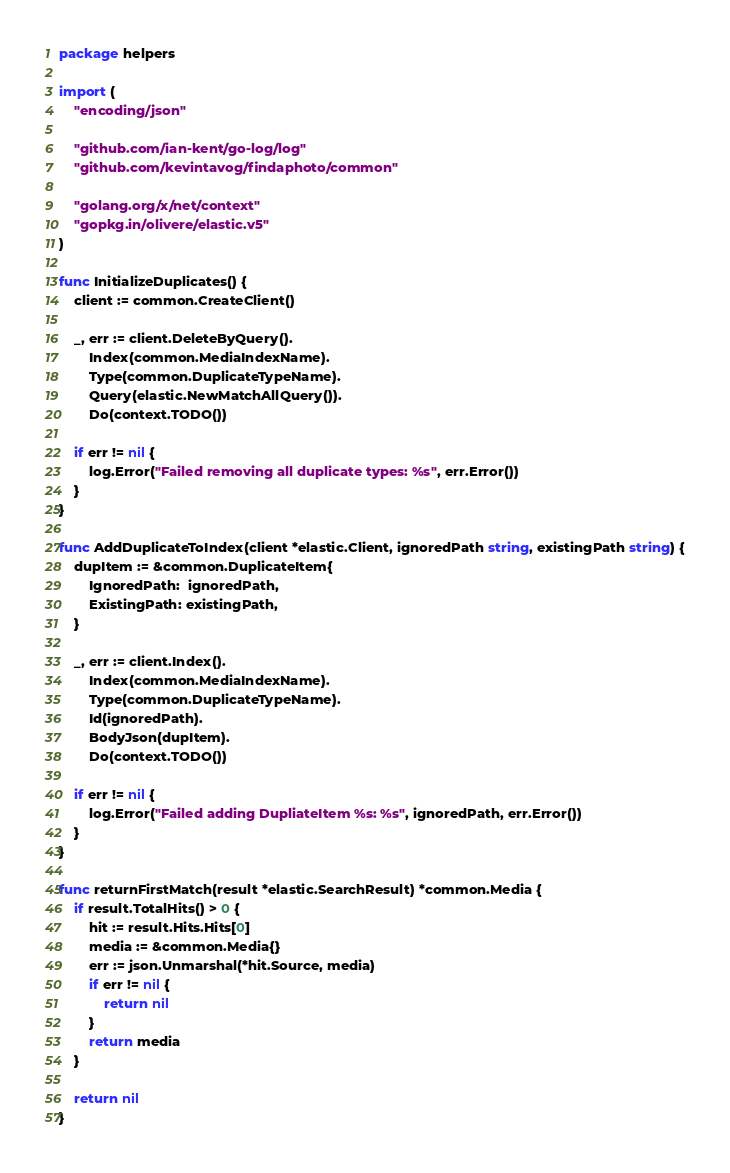<code> <loc_0><loc_0><loc_500><loc_500><_Go_>package helpers

import (
	"encoding/json"

	"github.com/ian-kent/go-log/log"
	"github.com/kevintavog/findaphoto/common"

	"golang.org/x/net/context"
	"gopkg.in/olivere/elastic.v5"
)

func InitializeDuplicates() {
	client := common.CreateClient()

	_, err := client.DeleteByQuery().
		Index(common.MediaIndexName).
		Type(common.DuplicateTypeName).
		Query(elastic.NewMatchAllQuery()).
		Do(context.TODO())

	if err != nil {
		log.Error("Failed removing all duplicate types: %s", err.Error())
	}
}

func AddDuplicateToIndex(client *elastic.Client, ignoredPath string, existingPath string) {
	dupItem := &common.DuplicateItem{
		IgnoredPath:  ignoredPath,
		ExistingPath: existingPath,
	}

	_, err := client.Index().
		Index(common.MediaIndexName).
		Type(common.DuplicateTypeName).
		Id(ignoredPath).
		BodyJson(dupItem).
		Do(context.TODO())

	if err != nil {
		log.Error("Failed adding DupliateItem %s: %s", ignoredPath, err.Error())
	}
}

func returnFirstMatch(result *elastic.SearchResult) *common.Media {
	if result.TotalHits() > 0 {
		hit := result.Hits.Hits[0]
		media := &common.Media{}
		err := json.Unmarshal(*hit.Source, media)
		if err != nil {
			return nil
		}
		return media
	}

	return nil
}
</code> 